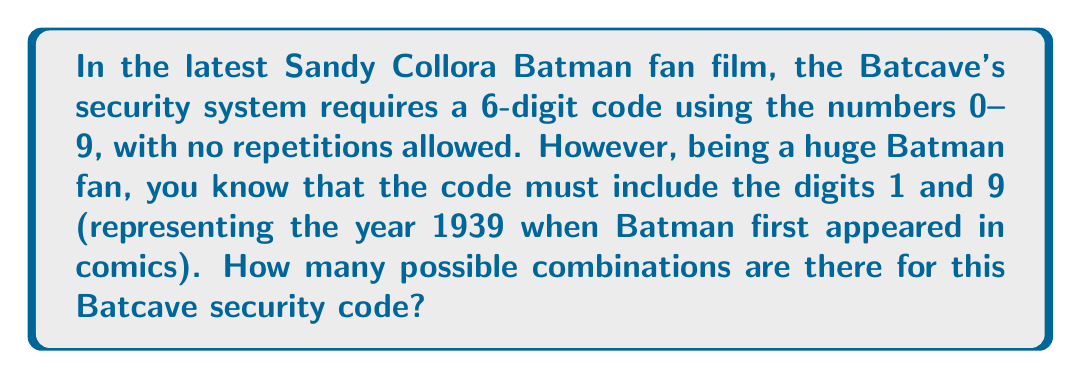Show me your answer to this math problem. Let's approach this step-by-step:

1) We need to choose 6 digits from 0-9, with no repetitions, and 1 and 9 must be included.

2) Since 1 and 9 are fixed, we need to choose 4 more digits from the remaining 8 digits (0, 2, 3, 4, 5, 6, 7, 8).

3) This is a combination problem, specifically a permutation because the order matters in a security code.

4) First, let's calculate how many ways we can choose 4 digits from 8:
   $$P(8,4) = \frac{8!}{(8-4)!} = \frac{8!}{4!} = 1680$$

5) Now, for each of these 1680 combinations, we need to consider all the ways to arrange these 4 digits along with 1 and 9.

6) Arranging 6 digits is a straightforward permutation:
   $$6! = 720$$

7) Therefore, the total number of possible combinations is:
   $$1680 \times 720 = 1,209,600$$
Answer: 1,209,600 